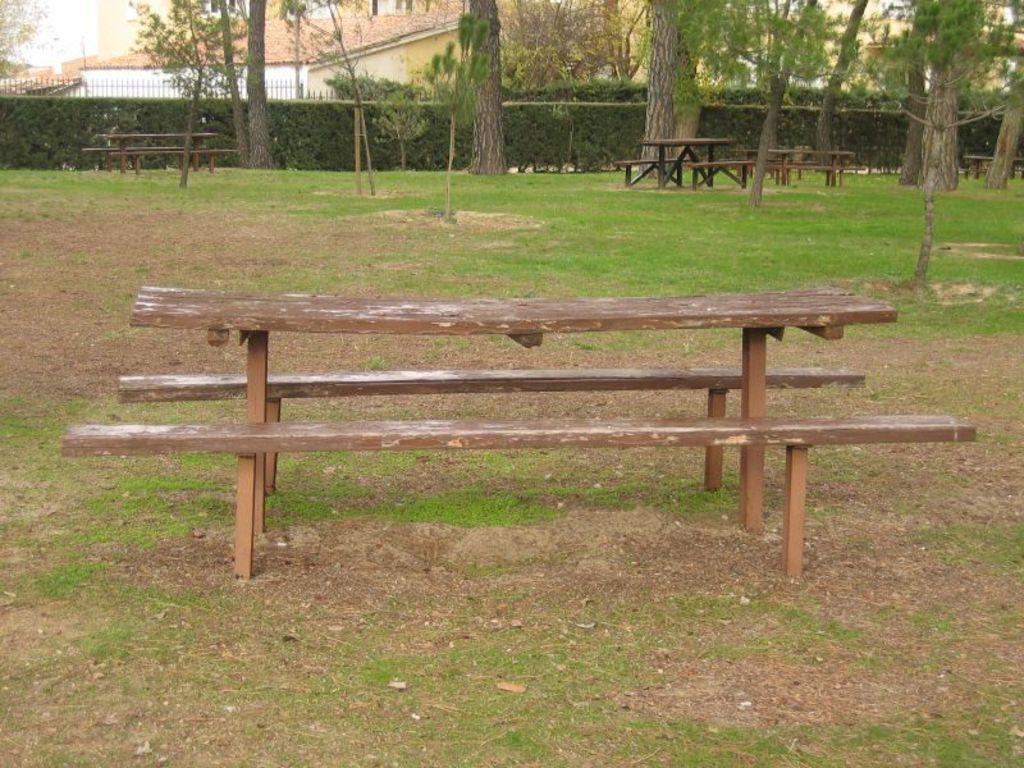Describe this image in one or two sentences. In this image I can see a wooden bench. Background I can see few trees in green color, a building in white color and sky also in white color. 